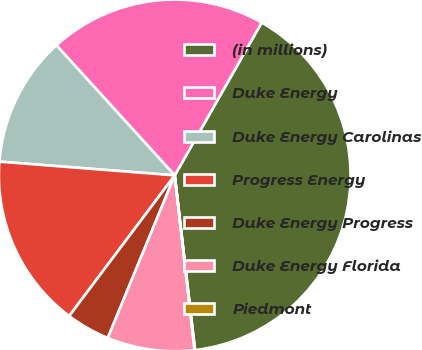<chart> <loc_0><loc_0><loc_500><loc_500><pie_chart><fcel>(in millions)<fcel>Duke Energy<fcel>Duke Energy Carolinas<fcel>Progress Energy<fcel>Duke Energy Progress<fcel>Duke Energy Florida<fcel>Piedmont<nl><fcel>39.93%<fcel>19.98%<fcel>12.01%<fcel>16.0%<fcel>4.03%<fcel>8.02%<fcel>0.04%<nl></chart> 